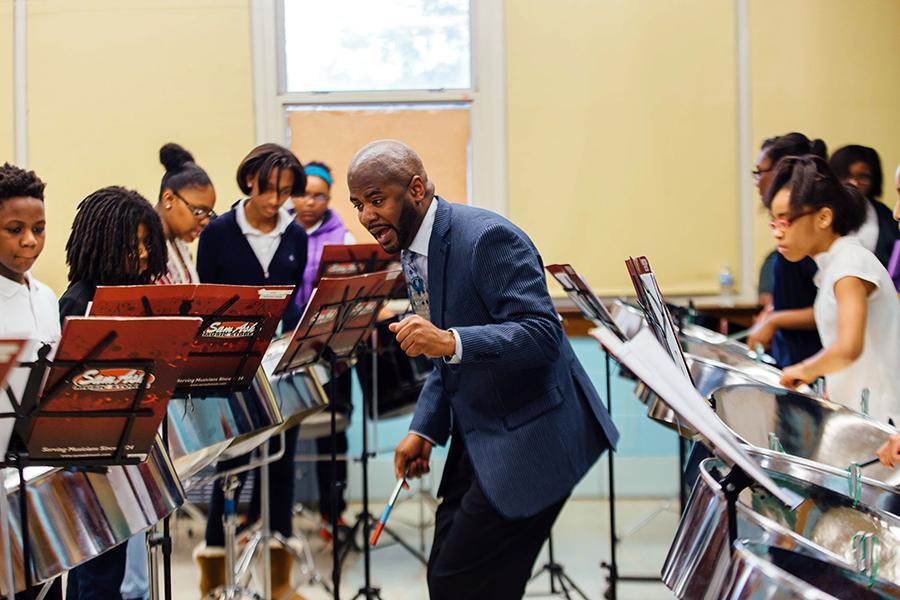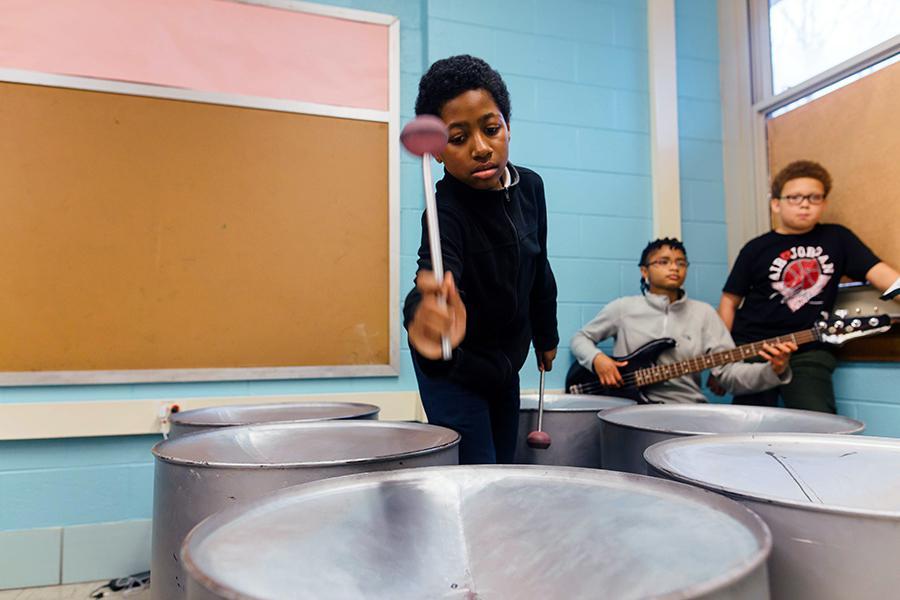The first image is the image on the left, the second image is the image on the right. Considering the images on both sides, is "In at least one image there are at least three women of color playing a fully metal drum." valid? Answer yes or no. Yes. The first image is the image on the left, the second image is the image on the right. Considering the images on both sides, is "Someone is holding an instrument that is not related to drums." valid? Answer yes or no. Yes. 